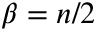Convert formula to latex. <formula><loc_0><loc_0><loc_500><loc_500>\beta = n / 2</formula> 